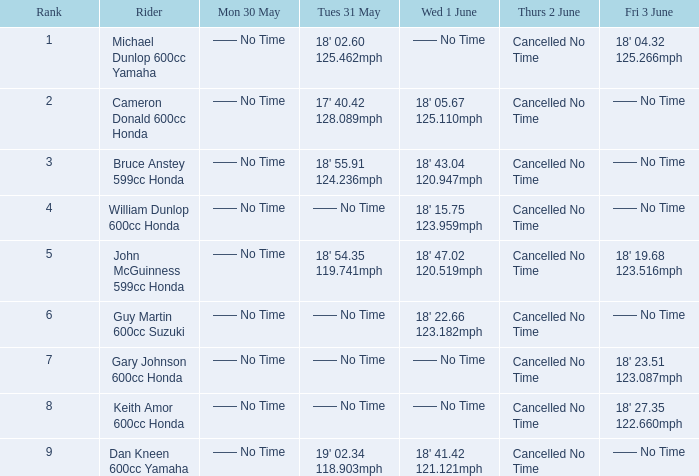What is the Fri 3 June time for the rider with a Weds 1 June time of 18' 22.66 123.182mph? —— No Time. 